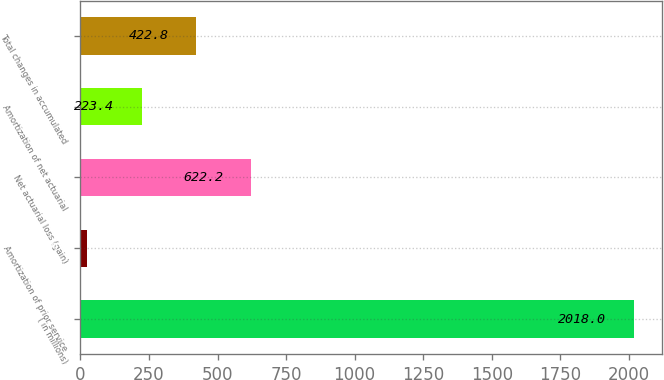Convert chart. <chart><loc_0><loc_0><loc_500><loc_500><bar_chart><fcel>( in millions)<fcel>Amortization of prior service<fcel>Net actuarial loss (gain)<fcel>Amortization of net actuarial<fcel>Total changes in accumulated<nl><fcel>2018<fcel>24<fcel>622.2<fcel>223.4<fcel>422.8<nl></chart> 